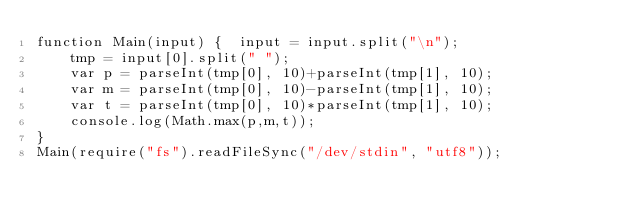Convert code to text. <code><loc_0><loc_0><loc_500><loc_500><_JavaScript_>function Main(input) {	input = input.split("\n");
	tmp = input[0].split(" ");
	var p = parseInt(tmp[0], 10)+parseInt(tmp[1], 10);
	var m = parseInt(tmp[0], 10)-parseInt(tmp[1], 10);
	var t = parseInt(tmp[0], 10)*parseInt(tmp[1], 10);
	console.log(Math.max(p,m,t));
}
Main(require("fs").readFileSync("/dev/stdin", "utf8"));</code> 